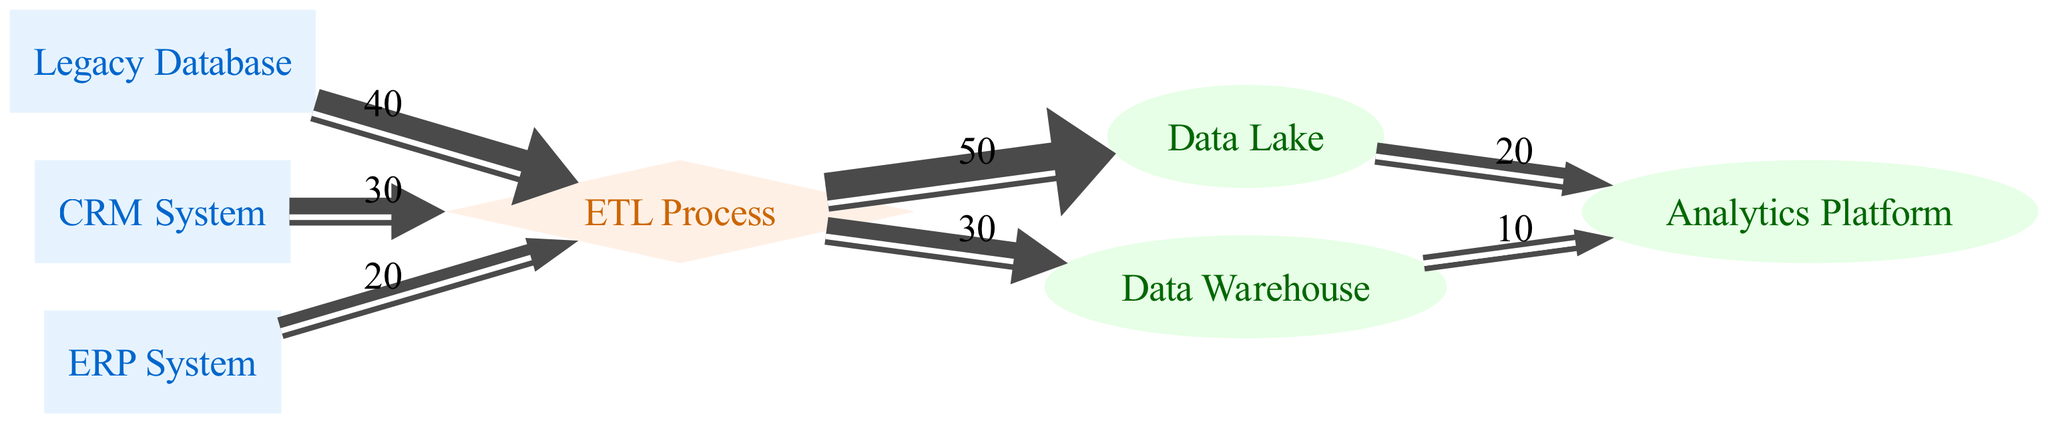What is the total data value coming from the Legacy Database? The Legacy Database feeds into the ETL Process with a data value of 40. This is the only direct connection, so the total value is simply that value.
Answer: 40 Which node receives data from both the CRM System and the ERP System? Both the CRM System and the ERP System link to the ETL Process. This is the transformation node that connects these two sources to the subsequent target nodes.
Answer: ETL Process How many target nodes are represented in the diagram? The target nodes listed are Data Lake, Data Warehouse, and Analytics Platform. Counting these gives a total of three target nodes.
Answer: 3 What is the total data value processed by the ETL Process? The ETL Process receives values of 40 from the Legacy Database, 30 from the CRM System, and 20 from the ERP System. Summing these values (40 + 30 + 20) gives 90 as the total incoming value.
Answer: 90 Which target node receives data from both the Data Lake and Data Warehouse? The target node Analytics Platform receives data from both the Data Lake (20) and the Data Warehouse (10). Therefore, this node aggregates data from the two previous nodes.
Answer: Analytics Platform What percentage of data from the ETL Process is sent to the Data Lake compared to total output? The ETL Process sends 50 to the Data Lake and 30 to the Data Warehouse, totaling 80. To find the percentage sent to Data Lake, (50/80)*100 = 62.5%.
Answer: 62.5% How much data does the Data Warehouse send to the Analytics Platform? The Data Warehouse sends a value of 10 to the Analytics Platform, which is the only outbound link from that node.
Answer: 10 What type of node is the ETL Process? In the diagram, the ETL Process is designated a transformation node. This categorization is indicated by its shape (diamond) and associated color styling.
Answer: transformation 